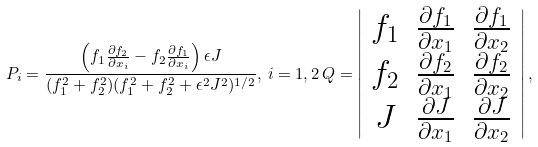<formula> <loc_0><loc_0><loc_500><loc_500>P _ { i } = \frac { \left ( f _ { 1 } \frac { \partial f _ { 2 } } { \partial x _ { i } } - f _ { 2 } \frac { \partial f _ { 1 } } { \partial x _ { i } } \right ) \epsilon J } { ( f _ { 1 } ^ { 2 } + f _ { 2 } ^ { 2 } ) ( f _ { 1 } ^ { 2 } + f _ { 2 } ^ { 2 } + \epsilon ^ { 2 } J ^ { 2 } ) ^ { 1 / 2 } } , \, i = 1 , 2 \, Q = \left | \begin{array} { c c c } f _ { 1 } & \frac { \partial f _ { 1 } } { \partial x _ { 1 } } & \frac { \partial f _ { 1 } } { \partial x _ { 2 } } \\ f _ { 2 } & \frac { \partial f _ { 2 } } { \partial x _ { 1 } } & \frac { \partial f _ { 2 } } { \partial x _ { 2 } } \\ J & \frac { \partial J } { \partial x _ { 1 } } & \frac { \partial J } { \partial x _ { 2 } } \end{array} \right | ,</formula> 